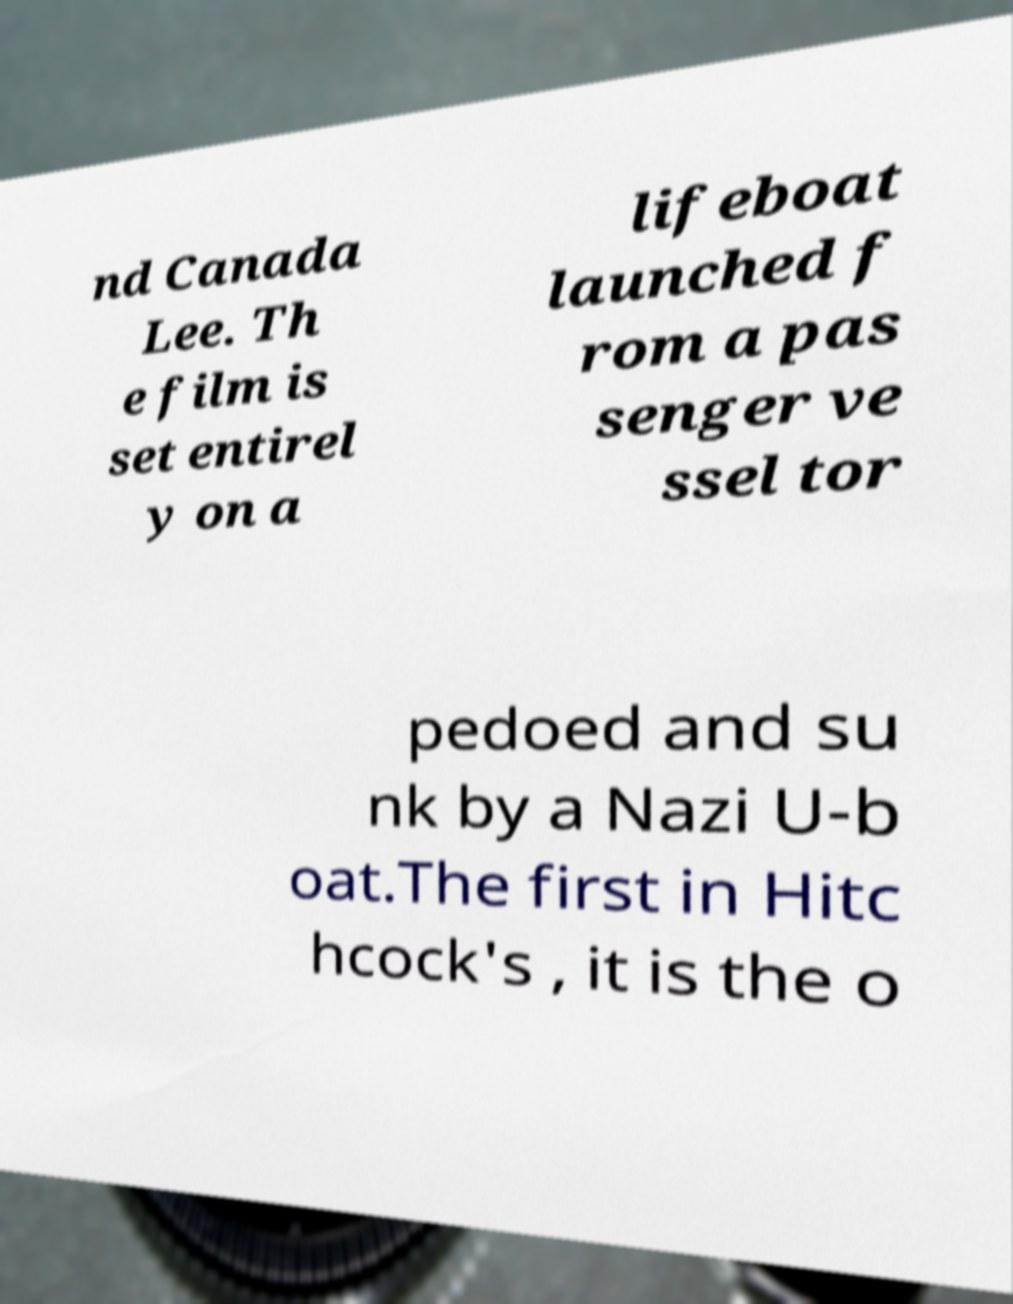What messages or text are displayed in this image? I need them in a readable, typed format. nd Canada Lee. Th e film is set entirel y on a lifeboat launched f rom a pas senger ve ssel tor pedoed and su nk by a Nazi U-b oat.The first in Hitc hcock's , it is the o 